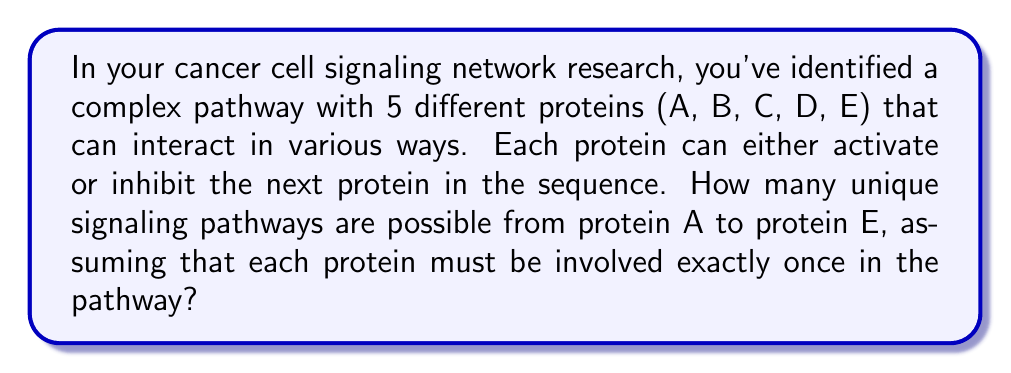Provide a solution to this math problem. Let's approach this step-by-step:

1) First, we need to consider the number of possible arrangements of the proteins. Since protein A must start the pathway and protein E must end it, we only need to arrange the middle 3 proteins (B, C, D). This is a permutation of 3 elements:

   $P(3) = 3! = 3 \times 2 \times 1 = 6$

2) Now, for each arrangement, we need to consider the interactions between adjacent proteins. Each protein can either activate or inhibit the next one. There are 4 interactions in total (A to the first middle protein, between the 3 middle proteins, and from the last middle protein to E).

3) For each interaction, there are 2 possibilities (activate or inhibit). Therefore, for each arrangement of proteins, there are:

   $2^4 = 16$ possible interaction combinations

4) By the multiplication principle, the total number of possible pathways is:

   $\text{Number of arrangements} \times \text{Number of interaction combinations per arrangement}$

   $= 6 \times 16 = 96$

Therefore, there are 96 unique signaling pathways possible in this network.
Answer: 96 